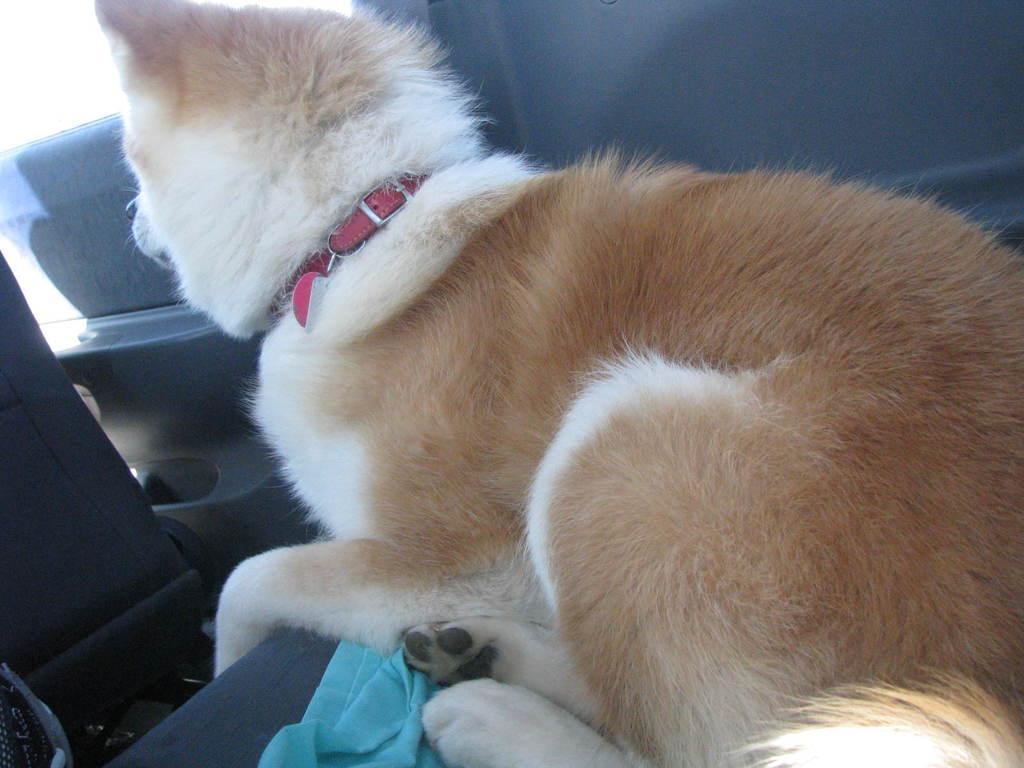How would you summarize this image in a sentence or two? In this image we can see an animal sitting and there is a cloth and the place looks like a inner view of a vehicle. 